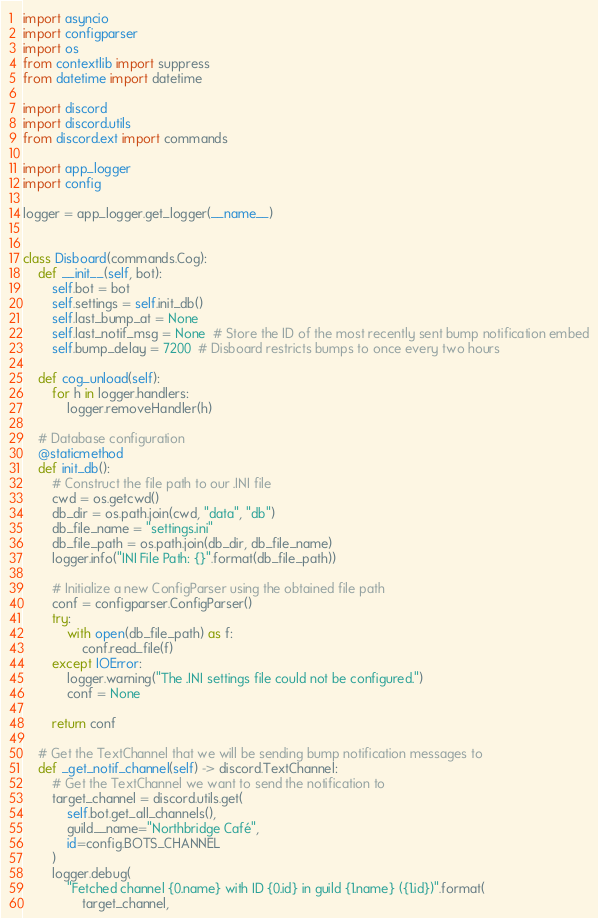<code> <loc_0><loc_0><loc_500><loc_500><_Python_>import asyncio
import configparser
import os
from contextlib import suppress
from datetime import datetime

import discord
import discord.utils
from discord.ext import commands

import app_logger
import config

logger = app_logger.get_logger(__name__)


class Disboard(commands.Cog):
    def __init__(self, bot):
        self.bot = bot
        self.settings = self.init_db()
        self.last_bump_at = None
        self.last_notif_msg = None  # Store the ID of the most recently sent bump notification embed
        self.bump_delay = 7200  # Disboard restricts bumps to once every two hours

    def cog_unload(self):
        for h in logger.handlers:
            logger.removeHandler(h)

    # Database configuration
    @staticmethod
    def init_db():
        # Construct the file path to our .INI file
        cwd = os.getcwd()
        db_dir = os.path.join(cwd, "data", "db")
        db_file_name = "settings.ini"
        db_file_path = os.path.join(db_dir, db_file_name)
        logger.info("INI File Path: {}".format(db_file_path))

        # Initialize a new ConfigParser using the obtained file path
        conf = configparser.ConfigParser()
        try:
            with open(db_file_path) as f:
                conf.read_file(f)
        except IOError:
            logger.warning("The .INI settings file could not be configured.")
            conf = None

        return conf

    # Get the TextChannel that we will be sending bump notification messages to
    def _get_notif_channel(self) -> discord.TextChannel:
        # Get the TextChannel we want to send the notification to
        target_channel = discord.utils.get(
            self.bot.get_all_channels(),
            guild__name="Northbridge Café",
            id=config.BOTS_CHANNEL
        )
        logger.debug(
            "Fetched channel {0.name} with ID {0.id} in guild {1.name} ({1.id})".format(
                target_channel,</code> 